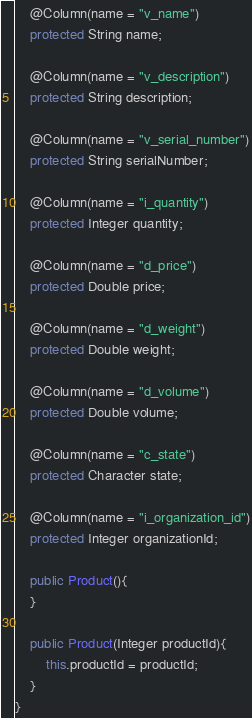<code> <loc_0><loc_0><loc_500><loc_500><_Java_>
	@Column(name = "v_name")
	protected String name;

	@Column(name = "v_description")
	protected String description;

	@Column(name = "v_serial_number")
	protected String serialNumber;

	@Column(name = "i_quantity")
	protected Integer quantity;

	@Column(name = "d_price")
	protected Double price;

	@Column(name = "d_weight")
	protected Double weight;

	@Column(name = "d_volume")
	protected Double volume;

	@Column(name = "c_state")
	protected Character state;

	@Column(name = "i_organization_id")
	protected Integer organizationId;

	public Product(){
	}

	public Product(Integer productId){
		this.productId = productId;
	}
}</code> 